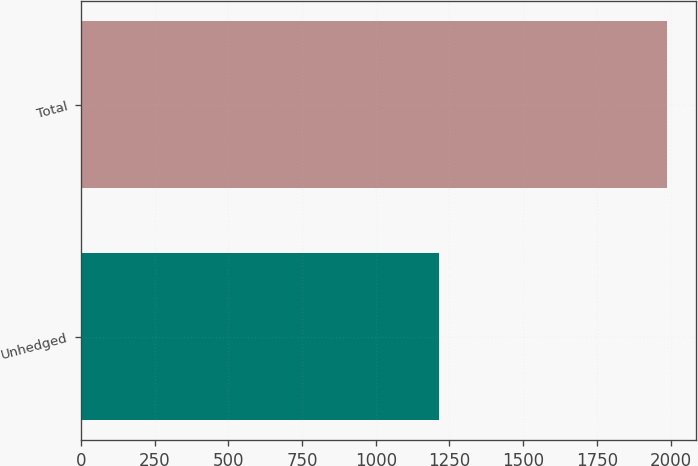<chart> <loc_0><loc_0><loc_500><loc_500><bar_chart><fcel>Unhedged<fcel>Total<nl><fcel>1215<fcel>1987<nl></chart> 